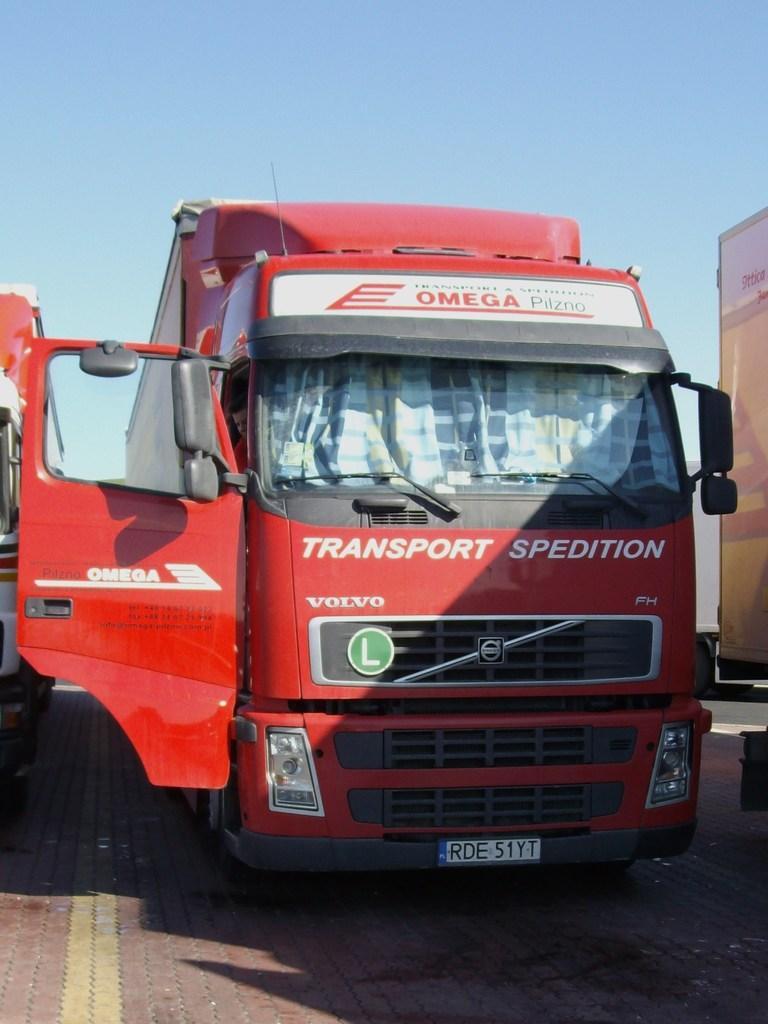In one or two sentences, can you explain what this image depicts? In this picture there is a vehicle which is in red color which has some thing written on it and there is another vehicle beside it. 